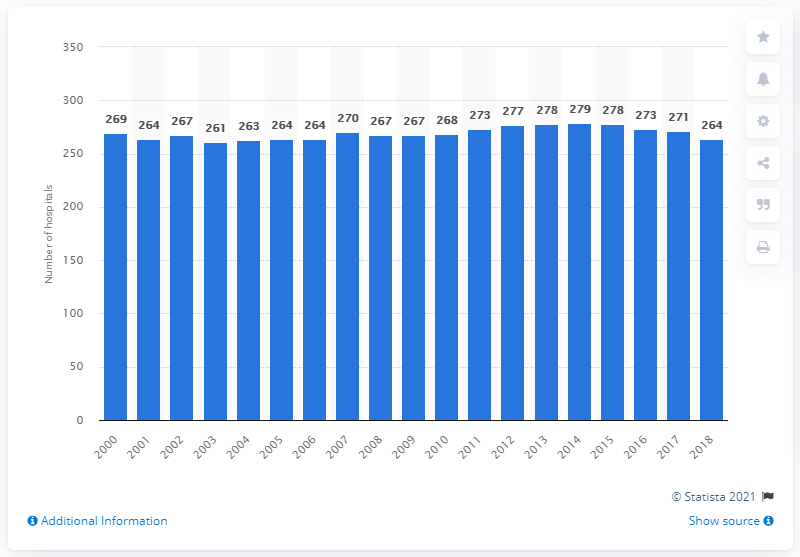Specify some key components in this picture. In 2018, there were 264 hospitals in Austria. The number of hospitals in Austria has remained stable since 2000. 